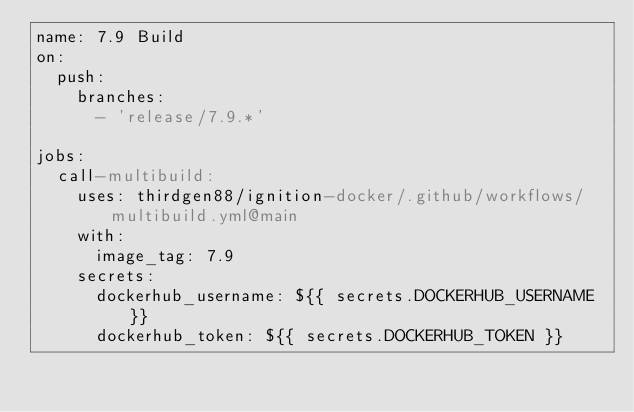Convert code to text. <code><loc_0><loc_0><loc_500><loc_500><_YAML_>name: 7.9 Build
on:
  push:
    branches:
      - 'release/7.9.*'

jobs:
  call-multibuild:
    uses: thirdgen88/ignition-docker/.github/workflows/multibuild.yml@main
    with:
      image_tag: 7.9
    secrets:
      dockerhub_username: ${{ secrets.DOCKERHUB_USERNAME }}
      dockerhub_token: ${{ secrets.DOCKERHUB_TOKEN }}
</code> 